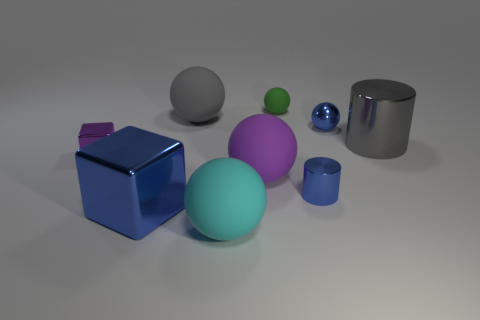Are there more purple balls that are behind the large blue cube than large gray rubber spheres that are to the left of the small green thing?
Provide a succinct answer. No. There is a large gray thing on the right side of the small green object; what number of gray cylinders are left of it?
Ensure brevity in your answer.  0. There is a ball that is the same color as the large cylinder; what material is it?
Your answer should be very brief. Rubber. What number of other things are there of the same color as the tiny metallic sphere?
Offer a terse response. 2. There is a small object that is on the left side of the big metallic object left of the green rubber object; what color is it?
Your answer should be compact. Purple. Is there a metallic cube that has the same color as the big metal cylinder?
Offer a very short reply. No. How many matte things are large red cylinders or tiny green objects?
Give a very brief answer. 1. Are there any tiny blue things that have the same material as the gray ball?
Provide a succinct answer. No. What number of things are left of the large gray shiny cylinder and to the right of the tiny purple metallic cube?
Provide a short and direct response. 7. Are there fewer cylinders that are behind the purple metallic thing than objects that are in front of the shiny ball?
Your response must be concise. Yes. 